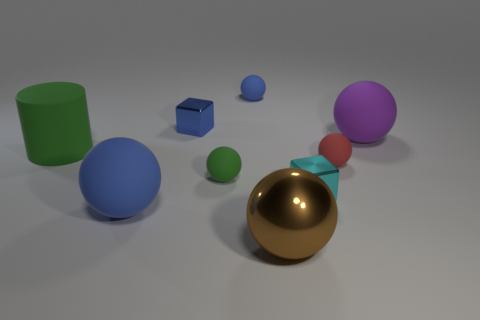Subtract all large purple matte balls. How many balls are left? 5 Subtract all cyan cubes. How many cubes are left? 1 Add 6 tiny cyan blocks. How many tiny cyan blocks are left? 7 Add 4 shiny objects. How many shiny objects exist? 7 Add 1 small cyan shiny cubes. How many objects exist? 10 Subtract 0 green blocks. How many objects are left? 9 Subtract all cubes. How many objects are left? 7 Subtract 1 cylinders. How many cylinders are left? 0 Subtract all yellow spheres. Subtract all red cubes. How many spheres are left? 6 Subtract all gray cylinders. How many blue balls are left? 2 